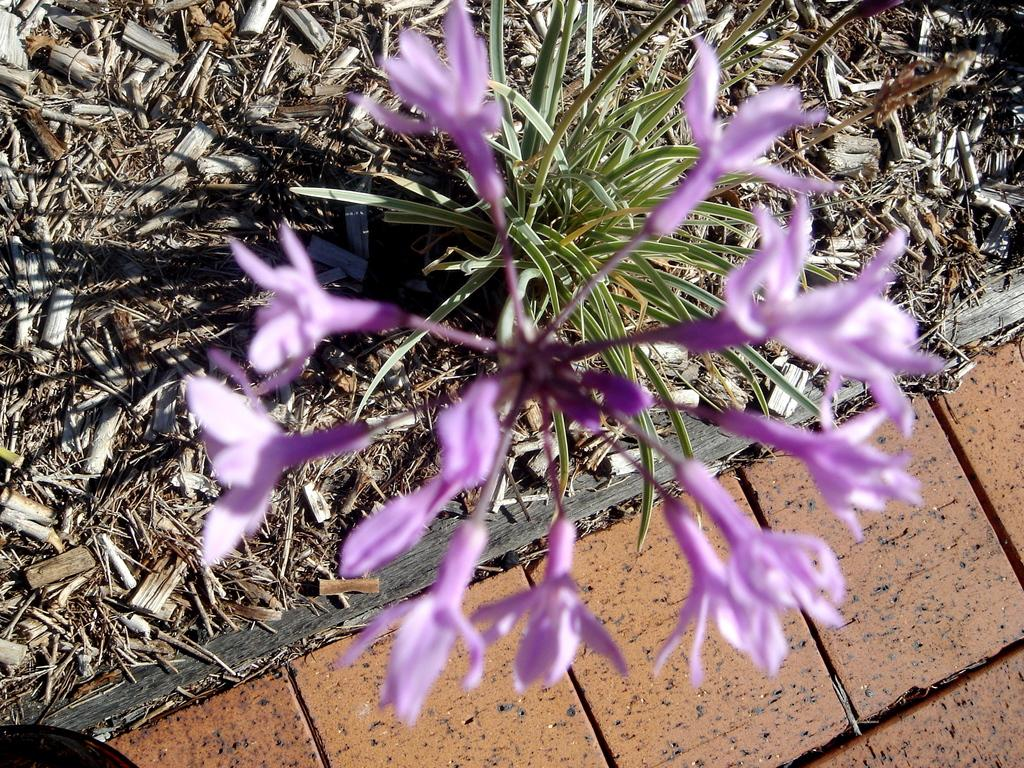What color are the flowers in the image? The flowers in the image are purple-colored. What other elements can be seen in the image besides the flowers? There are green-colored leaves in the image. How many rings can be seen on the back of the flower in the image? There are no rings visible on the flowers or any other elements in the image, as it only features purple-colored flowers and green-colored leaves. 